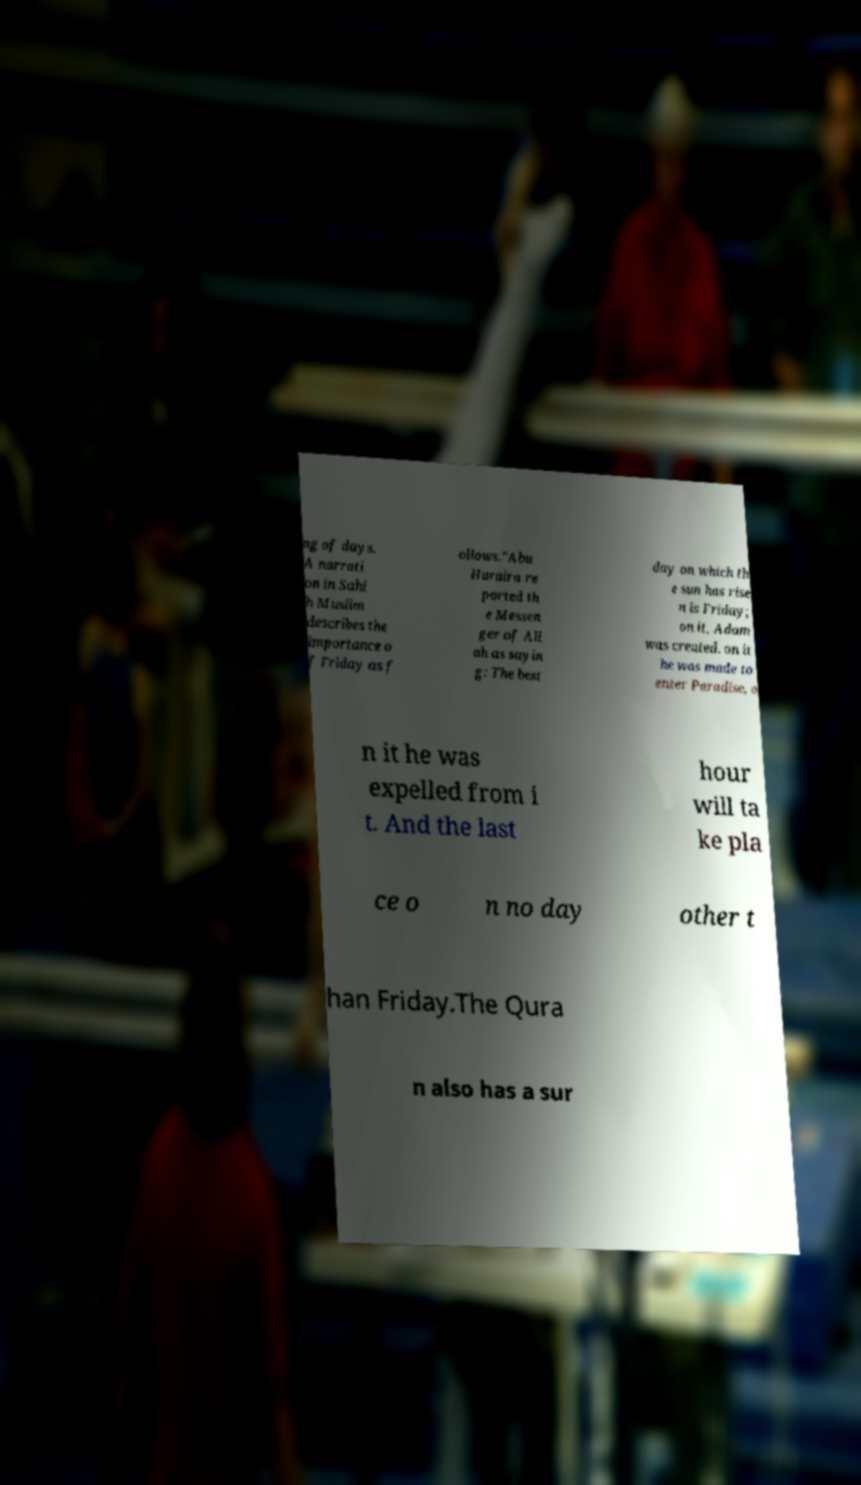For documentation purposes, I need the text within this image transcribed. Could you provide that? ng of days. A narrati on in Sahi h Muslim describes the importance o f Friday as f ollows."Abu Huraira re ported th e Messen ger of All ah as sayin g: The best day on which th e sun has rise n is Friday; on it, Adam was created. on it he was made to enter Paradise, o n it he was expelled from i t. And the last hour will ta ke pla ce o n no day other t han Friday.The Qura n also has a sur 